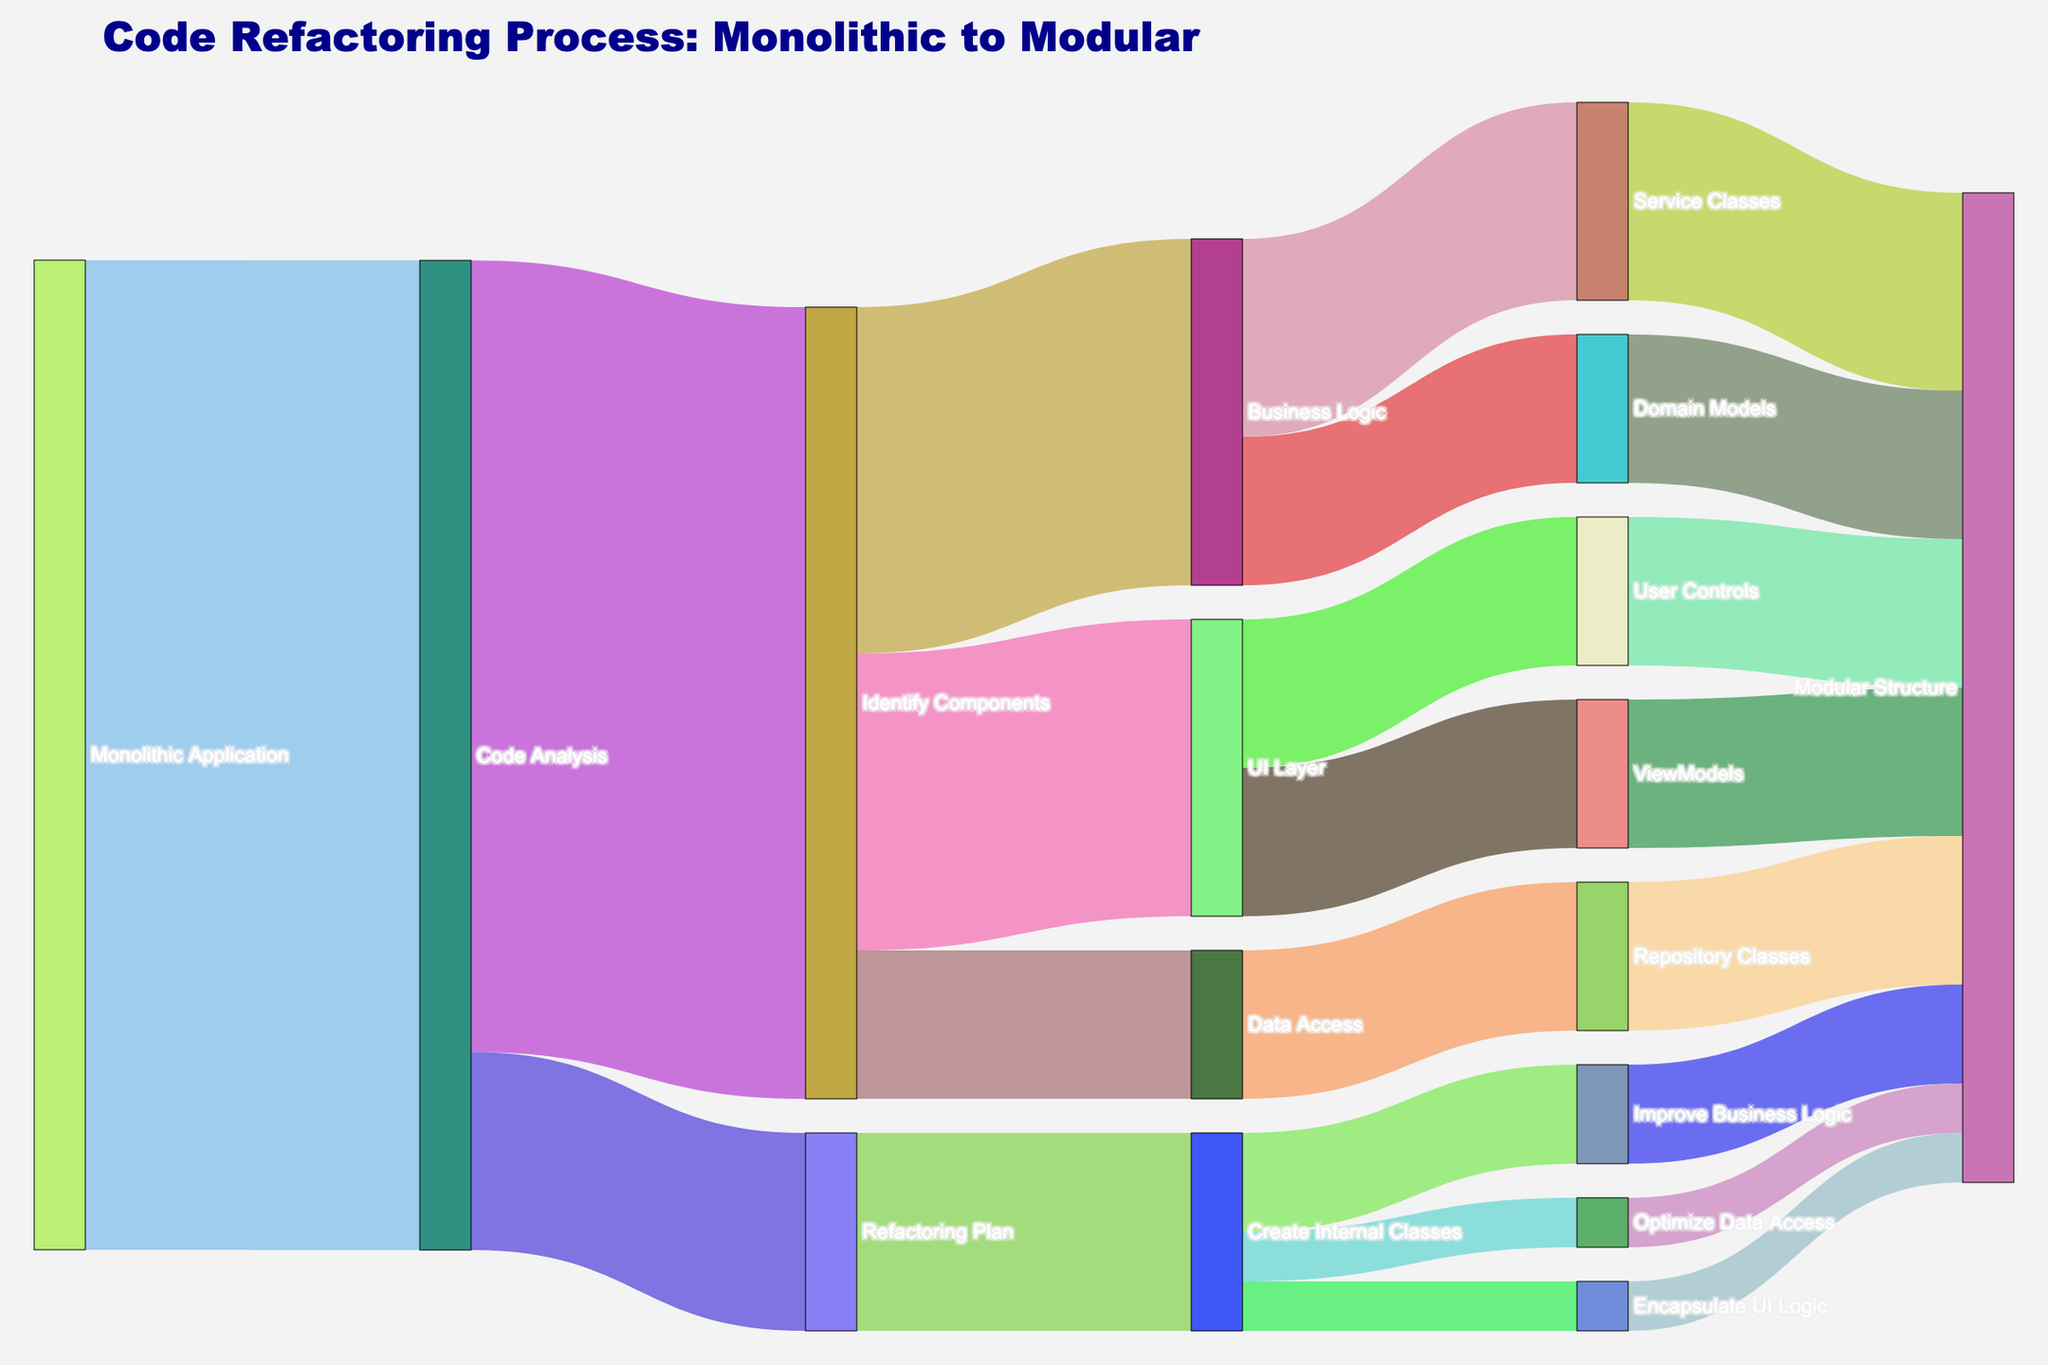What is the first step in the code refactoring process according to the diagram? The first step in the code refactoring process is "Code Analysis" which is connected directly from the "Monolithic Application."
Answer: Code Analysis How many steps are involved from "Monolithic Application" to "Modular Structure"? To count the steps, trace the path: "Monolithic Application" -> "Code Analysis" -> "Identify Components" -> specific components (e.g., "UI Layer") -> sub-components (e.g., "ViewModels") -> "Modular Structure". This sequence involves 5 steps.
Answer: 5 What is the number of values connected from "Identify Components"? The node "Identify Components" is connected to three nodes: "UI Layer", "Business Logic", and "Data Access" with values 30, 35, and 15, respectively. The total values are 30 + 35 + 15 = 80.
Answer: 80 Which component has the highest value flowing into "Modular Structure"? By tracing the paths leading to "Modular Structure," we see the values: "Service Classes" (20), "ViewModels" (15), "User Controls" (15), "Domain Models" (15), "Repository Classes" (15), "Encapsulate UI Logic" (5), "Improve Business Logic" (10), and "Optimize Data Access" (5). The maximum value here is 20 from "Service Classes."
Answer: Service Classes What percentage of the total flow from "Identify Components" goes into "Business Logic"? The total flow from "Identify Components" sums up to 30 + 35 + 15 = 80. The flow into "Business Logic" alone is 35. The percentage is calculated as (35 / 80) * 100 %.
Answer: 43.75% Which paths directly contribute to the "Modular Structure" from "Create Internal Classes"? "Create Internal Classes" connects directly to "Encapsulate UI Logic" (5), "Improve Business Logic" (10), and "Optimize Data Access" (5), each of which leads to "Modular Structure".
Answer: Encapsulate UI Logic, Improve Business Logic, Optimize Data Access How many nodes lead directly into the "ViewModels" component? According to the diagram, only one node "UI Layer" leads directly into "ViewModels".
Answer: 1 What is the combined flow value of all paths ending in "Repository Classes"? "Repository Classes" receives value directly from "Data Access" which has a value of 15. There are no other contributing paths shown to "Repository Classes".
Answer: 15 